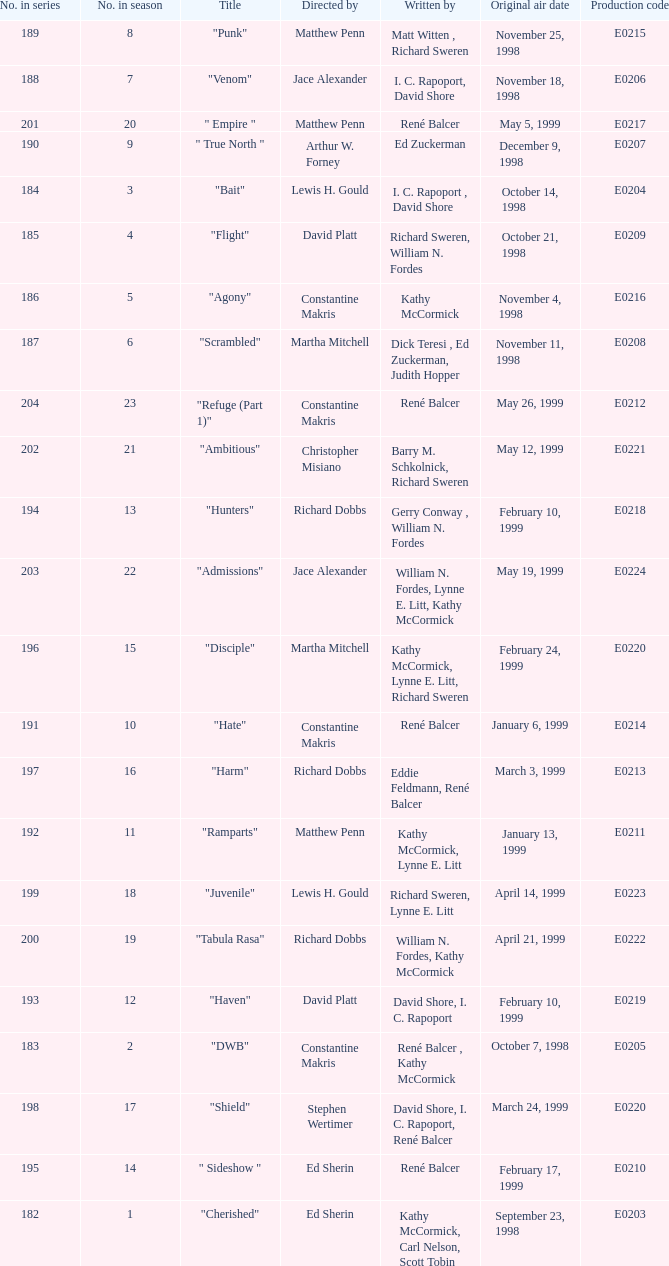The episode with the title "Bait" has what original air date? October 14, 1998. 